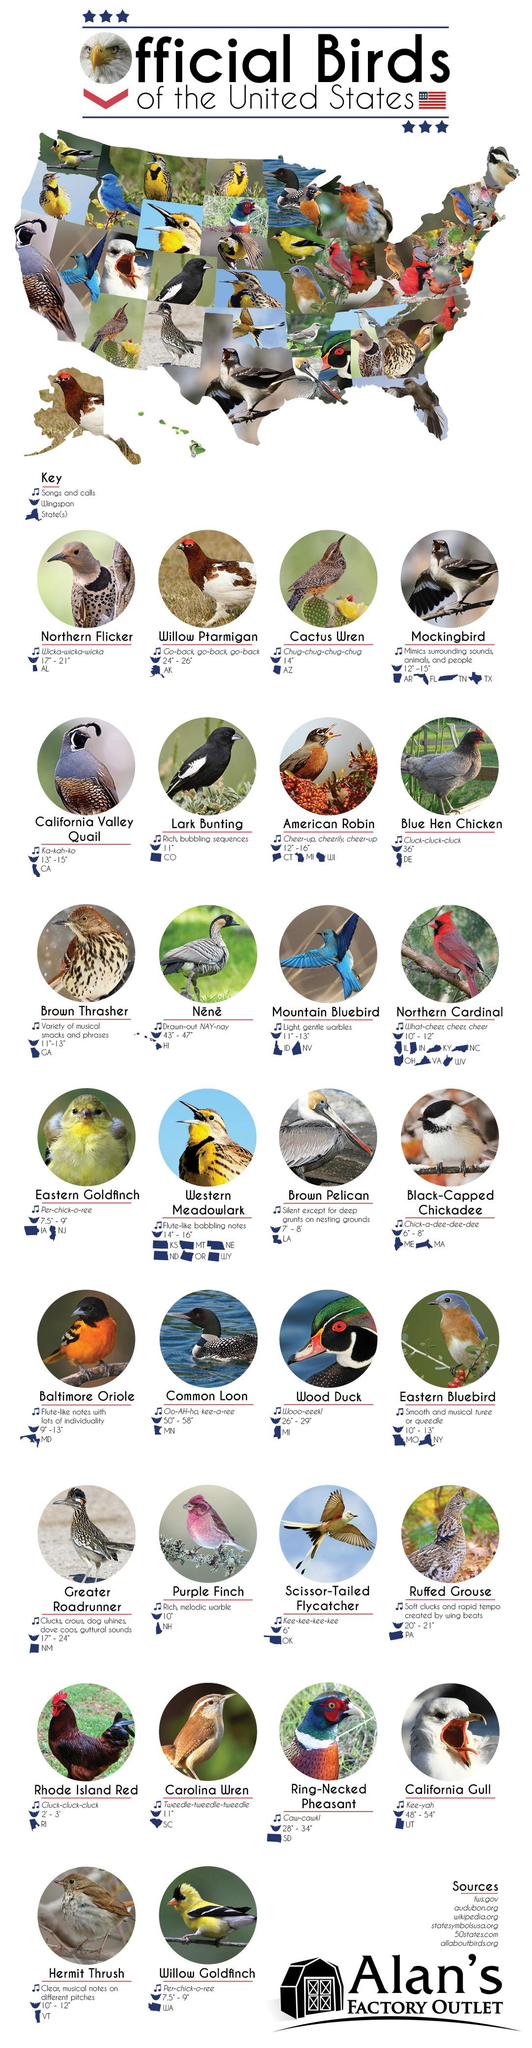Indicate a few pertinent items in this graphic. The Western Meadowlark is found in six states. The Purple Finch has a rich, melodic warble that serves as its song or call. The Willow Ptarmigan is found in the state of Alaska. The bird known as the Cactus Wren can be found in the state of Arizona. The wingspan of the Great Roadrunner ranges from 17 inches to 24 inches. 